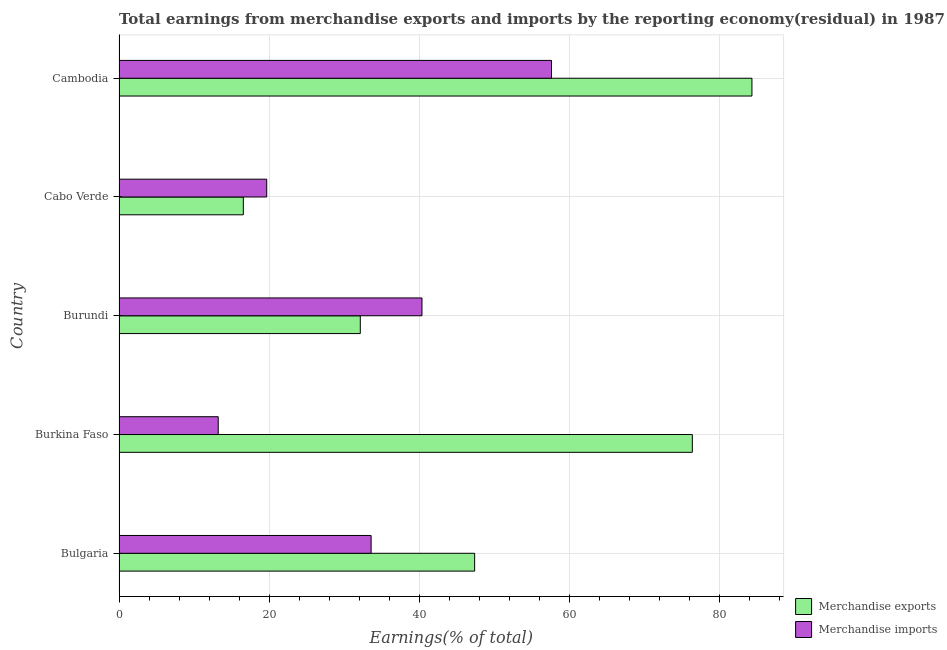How many different coloured bars are there?
Your answer should be compact. 2. Are the number of bars on each tick of the Y-axis equal?
Ensure brevity in your answer.  Yes. How many bars are there on the 3rd tick from the top?
Give a very brief answer. 2. What is the label of the 4th group of bars from the top?
Provide a short and direct response. Burkina Faso. What is the earnings from merchandise imports in Cambodia?
Offer a terse response. 57.64. Across all countries, what is the maximum earnings from merchandise exports?
Your answer should be compact. 84.35. Across all countries, what is the minimum earnings from merchandise imports?
Offer a very short reply. 13.22. In which country was the earnings from merchandise exports maximum?
Your answer should be very brief. Cambodia. In which country was the earnings from merchandise exports minimum?
Provide a short and direct response. Cabo Verde. What is the total earnings from merchandise exports in the graph?
Make the answer very short. 256.86. What is the difference between the earnings from merchandise exports in Burkina Faso and that in Cabo Verde?
Offer a terse response. 59.84. What is the difference between the earnings from merchandise imports in Burkina Faso and the earnings from merchandise exports in Cabo Verde?
Make the answer very short. -3.34. What is the average earnings from merchandise imports per country?
Your response must be concise. 32.9. What is the difference between the earnings from merchandise exports and earnings from merchandise imports in Cabo Verde?
Make the answer very short. -3.12. In how many countries, is the earnings from merchandise imports greater than 20 %?
Offer a terse response. 3. What is the ratio of the earnings from merchandise imports in Burkina Faso to that in Burundi?
Your response must be concise. 0.33. Is the earnings from merchandise exports in Cabo Verde less than that in Cambodia?
Provide a short and direct response. Yes. What is the difference between the highest and the second highest earnings from merchandise imports?
Ensure brevity in your answer.  17.26. What is the difference between the highest and the lowest earnings from merchandise exports?
Provide a succinct answer. 67.79. In how many countries, is the earnings from merchandise imports greater than the average earnings from merchandise imports taken over all countries?
Make the answer very short. 3. How many bars are there?
Your answer should be very brief. 10. How many countries are there in the graph?
Provide a short and direct response. 5. What is the difference between two consecutive major ticks on the X-axis?
Provide a succinct answer. 20. Are the values on the major ticks of X-axis written in scientific E-notation?
Ensure brevity in your answer.  No. Does the graph contain any zero values?
Ensure brevity in your answer.  No. Where does the legend appear in the graph?
Provide a short and direct response. Bottom right. How many legend labels are there?
Your response must be concise. 2. How are the legend labels stacked?
Offer a terse response. Vertical. What is the title of the graph?
Your answer should be compact. Total earnings from merchandise exports and imports by the reporting economy(residual) in 1987. What is the label or title of the X-axis?
Make the answer very short. Earnings(% of total). What is the label or title of the Y-axis?
Give a very brief answer. Country. What is the Earnings(% of total) of Merchandise exports in Bulgaria?
Your answer should be very brief. 47.39. What is the Earnings(% of total) in Merchandise imports in Bulgaria?
Give a very brief answer. 33.59. What is the Earnings(% of total) in Merchandise exports in Burkina Faso?
Your response must be concise. 76.4. What is the Earnings(% of total) in Merchandise imports in Burkina Faso?
Provide a short and direct response. 13.22. What is the Earnings(% of total) of Merchandise exports in Burundi?
Your answer should be very brief. 32.15. What is the Earnings(% of total) of Merchandise imports in Burundi?
Your answer should be compact. 40.37. What is the Earnings(% of total) in Merchandise exports in Cabo Verde?
Make the answer very short. 16.56. What is the Earnings(% of total) of Merchandise imports in Cabo Verde?
Make the answer very short. 19.68. What is the Earnings(% of total) of Merchandise exports in Cambodia?
Make the answer very short. 84.35. What is the Earnings(% of total) in Merchandise imports in Cambodia?
Make the answer very short. 57.64. Across all countries, what is the maximum Earnings(% of total) in Merchandise exports?
Your answer should be very brief. 84.35. Across all countries, what is the maximum Earnings(% of total) in Merchandise imports?
Give a very brief answer. 57.64. Across all countries, what is the minimum Earnings(% of total) in Merchandise exports?
Keep it short and to the point. 16.56. Across all countries, what is the minimum Earnings(% of total) of Merchandise imports?
Make the answer very short. 13.22. What is the total Earnings(% of total) in Merchandise exports in the graph?
Keep it short and to the point. 256.86. What is the total Earnings(% of total) of Merchandise imports in the graph?
Your answer should be very brief. 164.5. What is the difference between the Earnings(% of total) of Merchandise exports in Bulgaria and that in Burkina Faso?
Give a very brief answer. -29.01. What is the difference between the Earnings(% of total) of Merchandise imports in Bulgaria and that in Burkina Faso?
Offer a very short reply. 20.38. What is the difference between the Earnings(% of total) in Merchandise exports in Bulgaria and that in Burundi?
Provide a short and direct response. 15.24. What is the difference between the Earnings(% of total) of Merchandise imports in Bulgaria and that in Burundi?
Your answer should be very brief. -6.78. What is the difference between the Earnings(% of total) in Merchandise exports in Bulgaria and that in Cabo Verde?
Your answer should be compact. 30.83. What is the difference between the Earnings(% of total) in Merchandise imports in Bulgaria and that in Cabo Verde?
Ensure brevity in your answer.  13.91. What is the difference between the Earnings(% of total) of Merchandise exports in Bulgaria and that in Cambodia?
Keep it short and to the point. -36.96. What is the difference between the Earnings(% of total) in Merchandise imports in Bulgaria and that in Cambodia?
Your answer should be compact. -24.04. What is the difference between the Earnings(% of total) of Merchandise exports in Burkina Faso and that in Burundi?
Offer a very short reply. 44.25. What is the difference between the Earnings(% of total) of Merchandise imports in Burkina Faso and that in Burundi?
Keep it short and to the point. -27.15. What is the difference between the Earnings(% of total) of Merchandise exports in Burkina Faso and that in Cabo Verde?
Your response must be concise. 59.84. What is the difference between the Earnings(% of total) of Merchandise imports in Burkina Faso and that in Cabo Verde?
Make the answer very short. -6.46. What is the difference between the Earnings(% of total) of Merchandise exports in Burkina Faso and that in Cambodia?
Your answer should be very brief. -7.95. What is the difference between the Earnings(% of total) in Merchandise imports in Burkina Faso and that in Cambodia?
Keep it short and to the point. -44.42. What is the difference between the Earnings(% of total) in Merchandise exports in Burundi and that in Cabo Verde?
Provide a succinct answer. 15.59. What is the difference between the Earnings(% of total) in Merchandise imports in Burundi and that in Cabo Verde?
Your answer should be compact. 20.69. What is the difference between the Earnings(% of total) in Merchandise exports in Burundi and that in Cambodia?
Your answer should be compact. -52.2. What is the difference between the Earnings(% of total) of Merchandise imports in Burundi and that in Cambodia?
Your answer should be compact. -17.26. What is the difference between the Earnings(% of total) of Merchandise exports in Cabo Verde and that in Cambodia?
Keep it short and to the point. -67.79. What is the difference between the Earnings(% of total) of Merchandise imports in Cabo Verde and that in Cambodia?
Keep it short and to the point. -37.96. What is the difference between the Earnings(% of total) of Merchandise exports in Bulgaria and the Earnings(% of total) of Merchandise imports in Burkina Faso?
Your response must be concise. 34.17. What is the difference between the Earnings(% of total) in Merchandise exports in Bulgaria and the Earnings(% of total) in Merchandise imports in Burundi?
Make the answer very short. 7.02. What is the difference between the Earnings(% of total) of Merchandise exports in Bulgaria and the Earnings(% of total) of Merchandise imports in Cabo Verde?
Your answer should be compact. 27.71. What is the difference between the Earnings(% of total) of Merchandise exports in Bulgaria and the Earnings(% of total) of Merchandise imports in Cambodia?
Offer a terse response. -10.24. What is the difference between the Earnings(% of total) in Merchandise exports in Burkina Faso and the Earnings(% of total) in Merchandise imports in Burundi?
Keep it short and to the point. 36.03. What is the difference between the Earnings(% of total) of Merchandise exports in Burkina Faso and the Earnings(% of total) of Merchandise imports in Cabo Verde?
Make the answer very short. 56.72. What is the difference between the Earnings(% of total) in Merchandise exports in Burkina Faso and the Earnings(% of total) in Merchandise imports in Cambodia?
Ensure brevity in your answer.  18.77. What is the difference between the Earnings(% of total) of Merchandise exports in Burundi and the Earnings(% of total) of Merchandise imports in Cabo Verde?
Your response must be concise. 12.47. What is the difference between the Earnings(% of total) of Merchandise exports in Burundi and the Earnings(% of total) of Merchandise imports in Cambodia?
Give a very brief answer. -25.48. What is the difference between the Earnings(% of total) in Merchandise exports in Cabo Verde and the Earnings(% of total) in Merchandise imports in Cambodia?
Make the answer very short. -41.07. What is the average Earnings(% of total) in Merchandise exports per country?
Your answer should be very brief. 51.37. What is the average Earnings(% of total) in Merchandise imports per country?
Keep it short and to the point. 32.9. What is the difference between the Earnings(% of total) of Merchandise exports and Earnings(% of total) of Merchandise imports in Bulgaria?
Your answer should be compact. 13.8. What is the difference between the Earnings(% of total) in Merchandise exports and Earnings(% of total) in Merchandise imports in Burkina Faso?
Offer a very short reply. 63.19. What is the difference between the Earnings(% of total) in Merchandise exports and Earnings(% of total) in Merchandise imports in Burundi?
Keep it short and to the point. -8.22. What is the difference between the Earnings(% of total) in Merchandise exports and Earnings(% of total) in Merchandise imports in Cabo Verde?
Provide a short and direct response. -3.12. What is the difference between the Earnings(% of total) of Merchandise exports and Earnings(% of total) of Merchandise imports in Cambodia?
Provide a succinct answer. 26.71. What is the ratio of the Earnings(% of total) of Merchandise exports in Bulgaria to that in Burkina Faso?
Give a very brief answer. 0.62. What is the ratio of the Earnings(% of total) of Merchandise imports in Bulgaria to that in Burkina Faso?
Make the answer very short. 2.54. What is the ratio of the Earnings(% of total) of Merchandise exports in Bulgaria to that in Burundi?
Make the answer very short. 1.47. What is the ratio of the Earnings(% of total) of Merchandise imports in Bulgaria to that in Burundi?
Your response must be concise. 0.83. What is the ratio of the Earnings(% of total) of Merchandise exports in Bulgaria to that in Cabo Verde?
Provide a succinct answer. 2.86. What is the ratio of the Earnings(% of total) of Merchandise imports in Bulgaria to that in Cabo Verde?
Your answer should be compact. 1.71. What is the ratio of the Earnings(% of total) in Merchandise exports in Bulgaria to that in Cambodia?
Make the answer very short. 0.56. What is the ratio of the Earnings(% of total) in Merchandise imports in Bulgaria to that in Cambodia?
Ensure brevity in your answer.  0.58. What is the ratio of the Earnings(% of total) in Merchandise exports in Burkina Faso to that in Burundi?
Give a very brief answer. 2.38. What is the ratio of the Earnings(% of total) of Merchandise imports in Burkina Faso to that in Burundi?
Your answer should be compact. 0.33. What is the ratio of the Earnings(% of total) in Merchandise exports in Burkina Faso to that in Cabo Verde?
Give a very brief answer. 4.61. What is the ratio of the Earnings(% of total) in Merchandise imports in Burkina Faso to that in Cabo Verde?
Offer a very short reply. 0.67. What is the ratio of the Earnings(% of total) of Merchandise exports in Burkina Faso to that in Cambodia?
Provide a short and direct response. 0.91. What is the ratio of the Earnings(% of total) in Merchandise imports in Burkina Faso to that in Cambodia?
Offer a terse response. 0.23. What is the ratio of the Earnings(% of total) of Merchandise exports in Burundi to that in Cabo Verde?
Give a very brief answer. 1.94. What is the ratio of the Earnings(% of total) in Merchandise imports in Burundi to that in Cabo Verde?
Ensure brevity in your answer.  2.05. What is the ratio of the Earnings(% of total) of Merchandise exports in Burundi to that in Cambodia?
Keep it short and to the point. 0.38. What is the ratio of the Earnings(% of total) in Merchandise imports in Burundi to that in Cambodia?
Keep it short and to the point. 0.7. What is the ratio of the Earnings(% of total) in Merchandise exports in Cabo Verde to that in Cambodia?
Your response must be concise. 0.2. What is the ratio of the Earnings(% of total) in Merchandise imports in Cabo Verde to that in Cambodia?
Keep it short and to the point. 0.34. What is the difference between the highest and the second highest Earnings(% of total) in Merchandise exports?
Offer a very short reply. 7.95. What is the difference between the highest and the second highest Earnings(% of total) in Merchandise imports?
Provide a succinct answer. 17.26. What is the difference between the highest and the lowest Earnings(% of total) in Merchandise exports?
Make the answer very short. 67.79. What is the difference between the highest and the lowest Earnings(% of total) in Merchandise imports?
Offer a terse response. 44.42. 